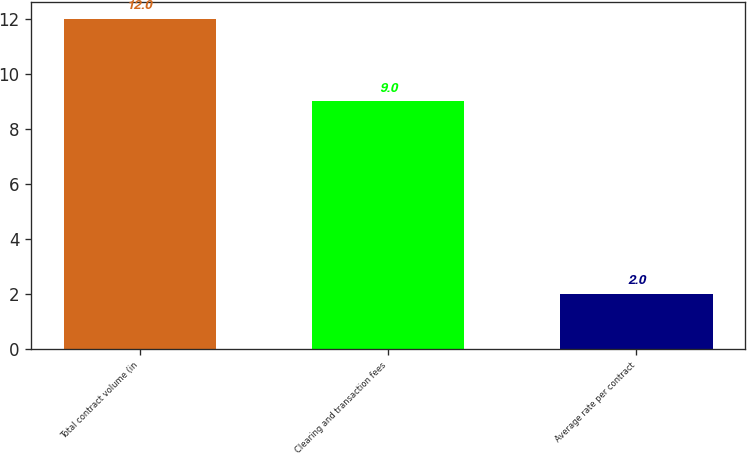Convert chart to OTSL. <chart><loc_0><loc_0><loc_500><loc_500><bar_chart><fcel>Total contract volume (in<fcel>Clearing and transaction fees<fcel>Average rate per contract<nl><fcel>12<fcel>9<fcel>2<nl></chart> 